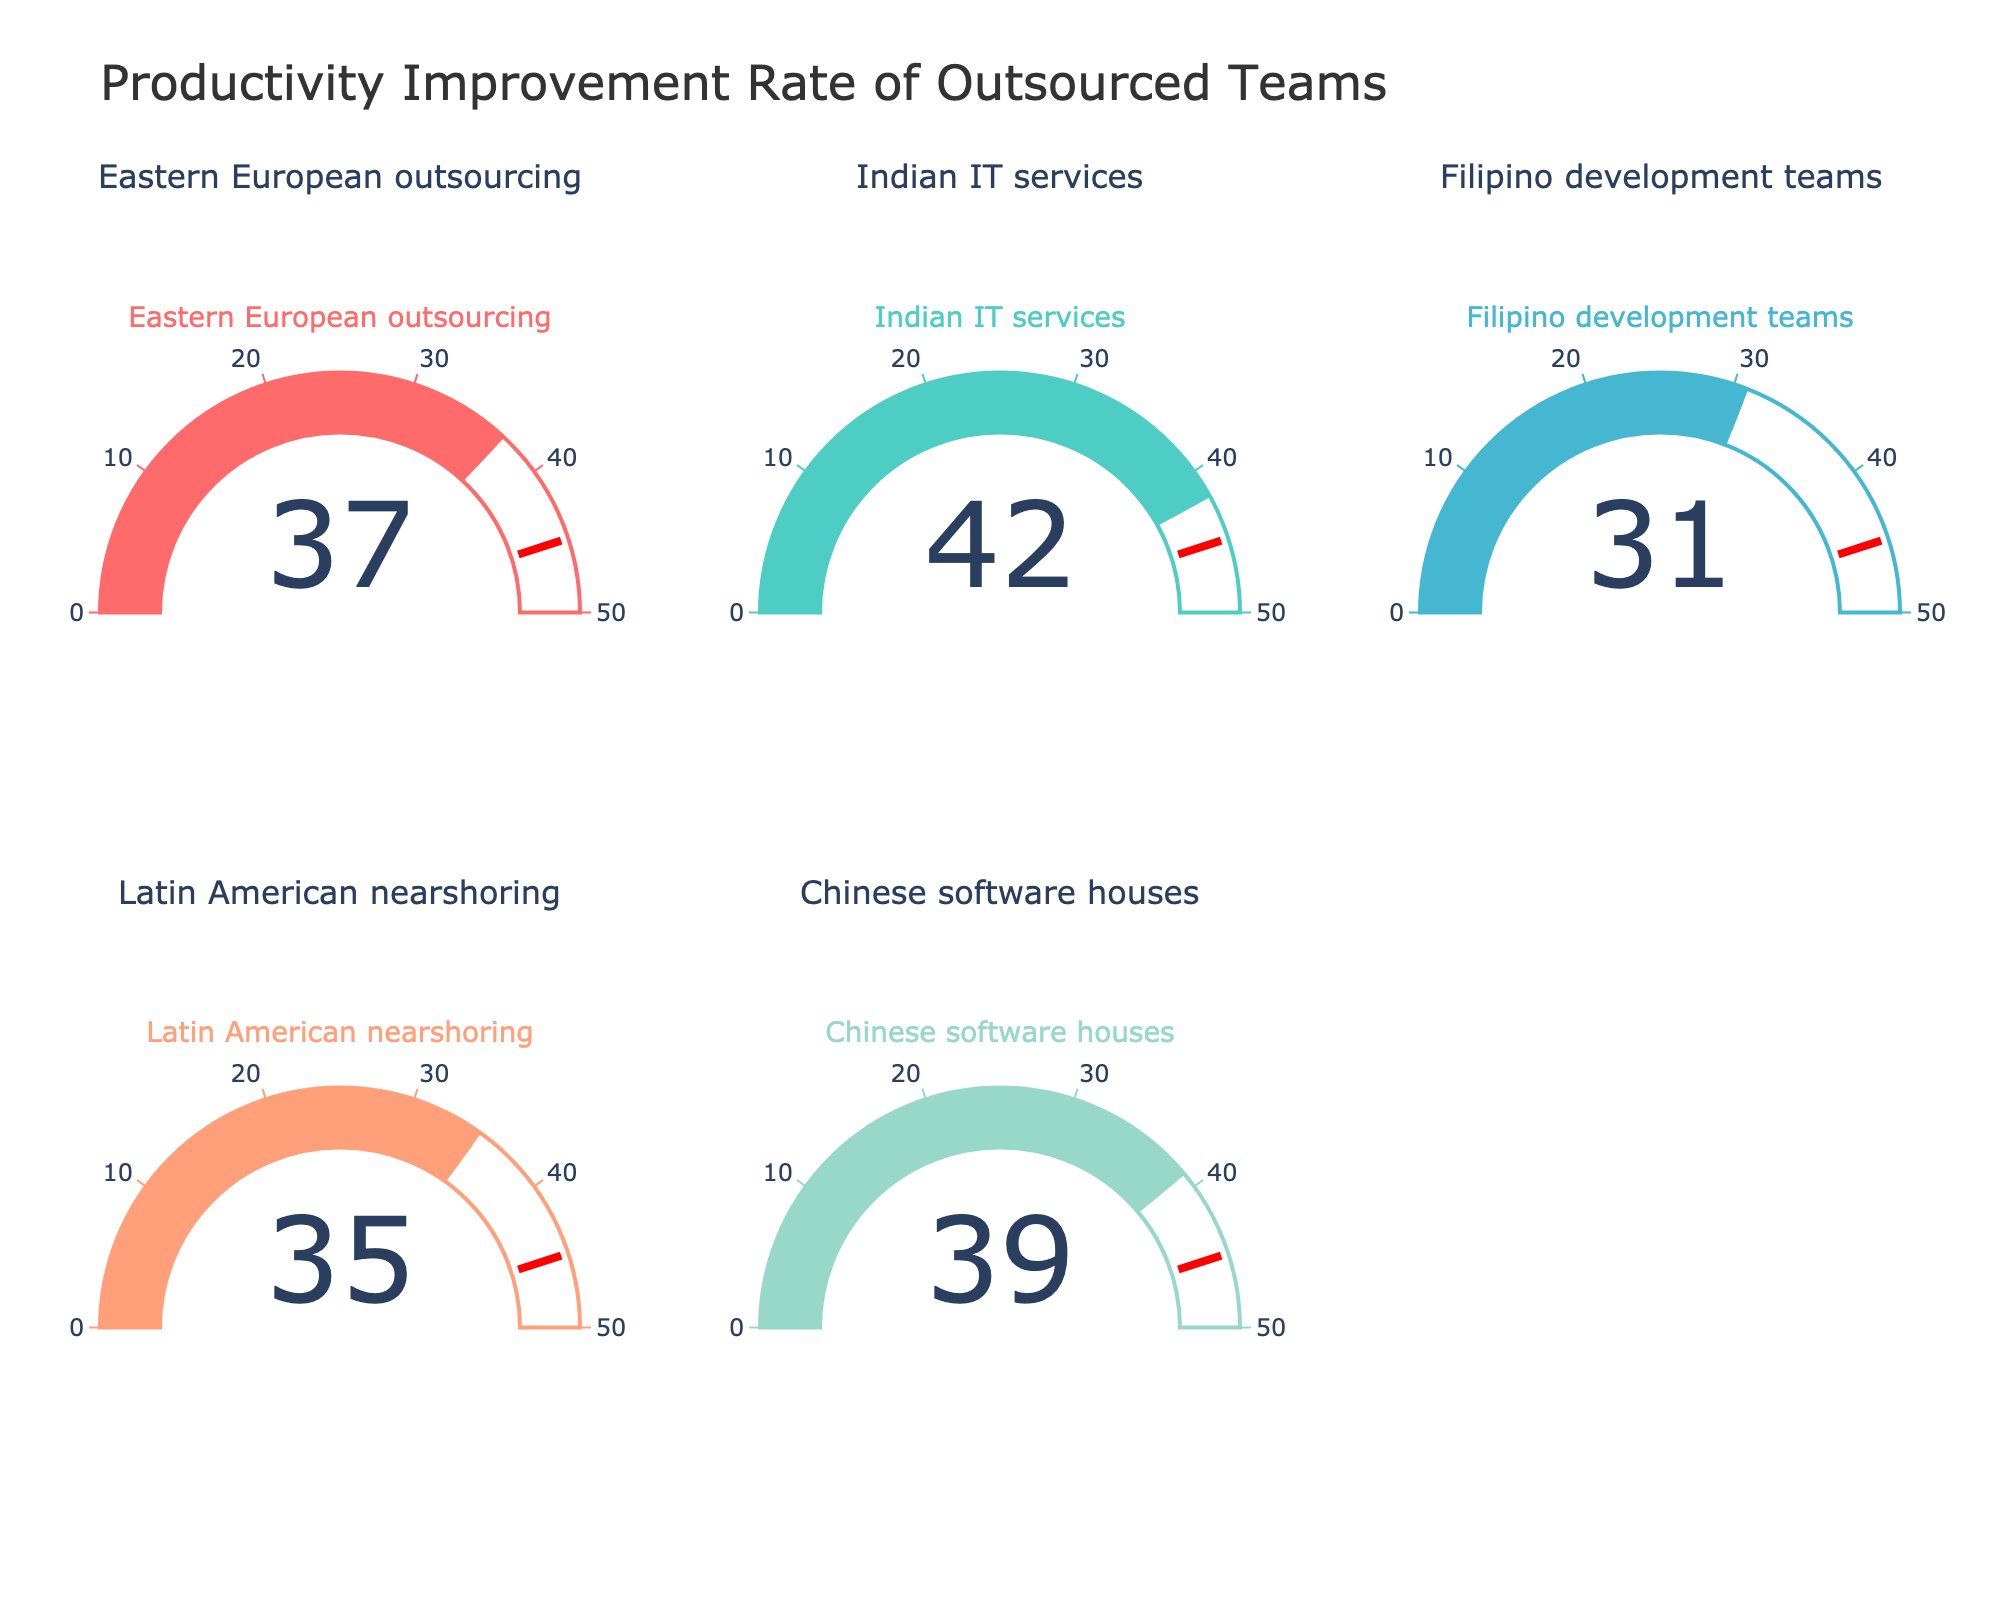What's the title of the figure? The title of the figure is displayed prominently at the top of the plot. The title reads "Productivity Improvement Rate of Outsourced Teams".
Answer: Productivity Improvement Rate of Outsourced Teams How many gauge charts are present in the figure? The plot contains a total of five gauge charts arranged in two rows, with three charts in the first row and two in the second row. The third spot in the second row is empty.
Answer: Five Which outsourced team has the highest productivity improvement rate? The gauge chart with the highest number indicates the highest productivity improvement rate. The Indian IT services team has a value of 42, which is the highest among the teams displayed.
Answer: Indian IT services What is the productivity improvement rate of Filipino development teams? The specific gauge chart for Filipino development teams shows the value, which is 31.
Answer: 31 Are any of the teams' productivity improvement rates above the threshold line? The threshold line on each gauge chart is set at a value of 45. No gauge in the plot shows a value above 45, so none of the teams' productivity improvement rates reach or exceed the threshold.
Answer: No Which two teams have productivity improvement rates closest to each other? The productivity improvement rates of Latin American nearshoring and Eastern European outsourcing are 35 and 37, respectively. The difference between these rates is 2, making them the closest to each other.
Answer: Latin American nearshoring and Eastern European outsourcing What is the average productivity improvement rate of all the outsourced teams? To find the average, sum up all the productivity improvement rates and divide by the number of teams. The rates are: 37, 42, 31, 35, and 39. The sum is 184. Dividing by the 5 teams gives an average of 36.8.
Answer: 36.8 Which team has a lower productivity improvement rate, Chinese software houses or Eastern European outsourcing? By comparing the values of Chinese software houses (39) and Eastern European outsourcing (37), Eastern European outsourcing has a lower rate.
Answer: Eastern European outsourcing Is the productivity improvement rate of Latin American nearshoring higher than Filipino development teams? Comparing the values, Latin American nearshoring has a rate of 35, while Filipino development teams have a rate of 31. Therefore, the rate for Latin American nearshoring is higher.
Answer: Yes What is the range of the productivity improvement rates displayed in the figure? The lowest improvement rate is 31 (Filipino development teams) and the highest is 42 (Indian IT services). The range is the difference between the highest and lowest values, which is 42 - 31 = 11.
Answer: 11 